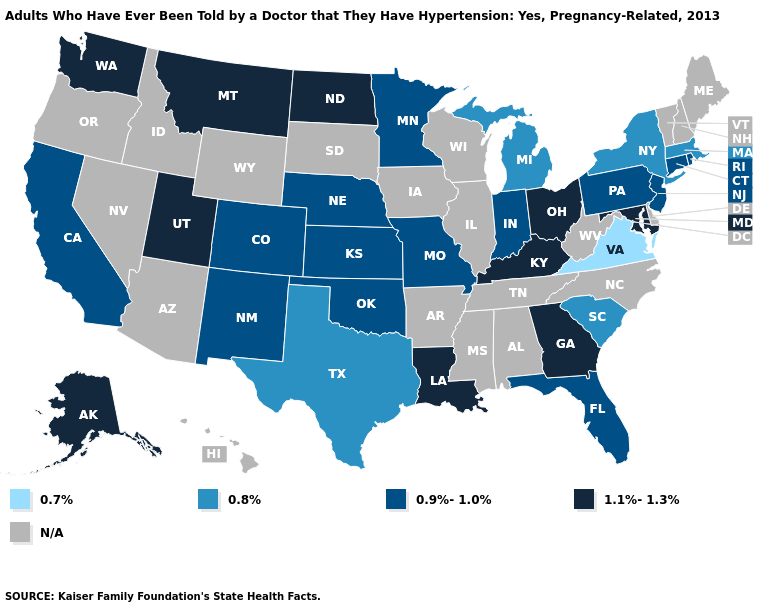Which states have the highest value in the USA?
Short answer required. Alaska, Georgia, Kentucky, Louisiana, Maryland, Montana, North Dakota, Ohio, Utah, Washington. What is the highest value in the West ?
Keep it brief. 1.1%-1.3%. Does Indiana have the lowest value in the MidWest?
Give a very brief answer. No. What is the value of Maryland?
Be succinct. 1.1%-1.3%. What is the value of Mississippi?
Short answer required. N/A. What is the value of Minnesota?
Give a very brief answer. 0.9%-1.0%. Does the first symbol in the legend represent the smallest category?
Short answer required. Yes. Name the states that have a value in the range N/A?
Answer briefly. Alabama, Arizona, Arkansas, Delaware, Hawaii, Idaho, Illinois, Iowa, Maine, Mississippi, Nevada, New Hampshire, North Carolina, Oregon, South Dakota, Tennessee, Vermont, West Virginia, Wisconsin, Wyoming. What is the lowest value in the West?
Be succinct. 0.9%-1.0%. Among the states that border Michigan , which have the lowest value?
Answer briefly. Indiana. Name the states that have a value in the range 0.7%?
Give a very brief answer. Virginia. What is the lowest value in the South?
Concise answer only. 0.7%. 